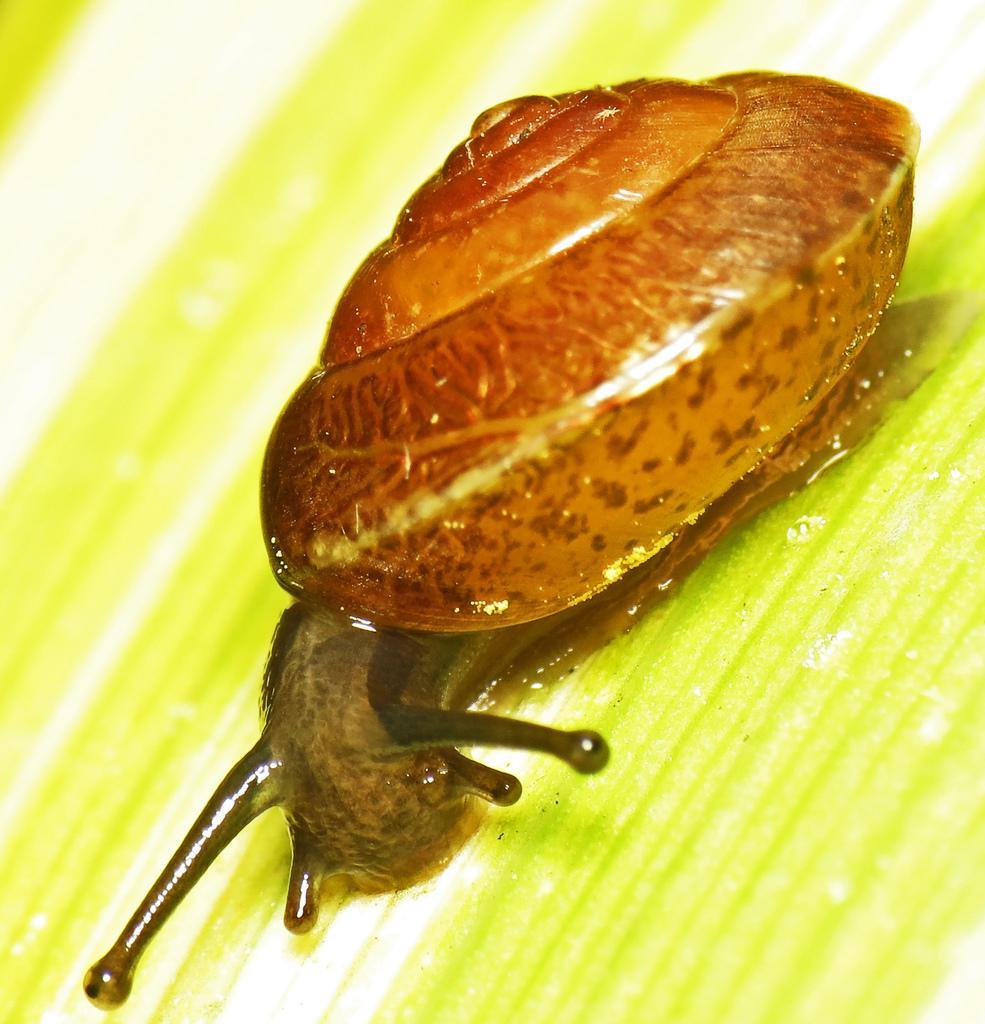Please provide a concise description of this image. Here in this picture we can see a snail present on a plant over there. 